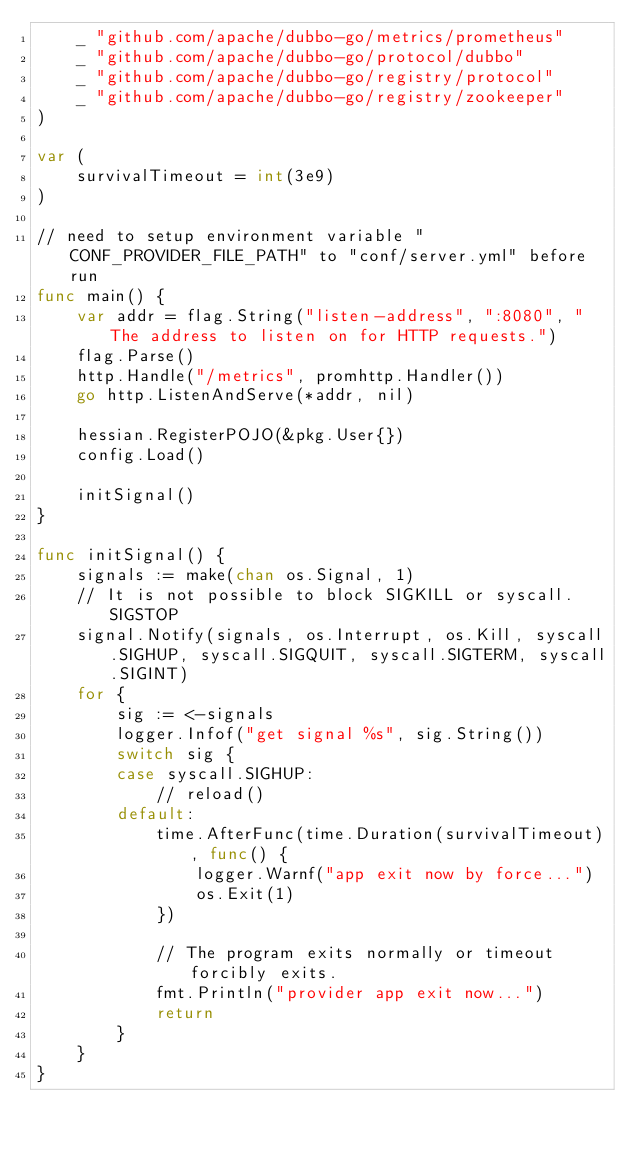Convert code to text. <code><loc_0><loc_0><loc_500><loc_500><_Go_>	_ "github.com/apache/dubbo-go/metrics/prometheus"
	_ "github.com/apache/dubbo-go/protocol/dubbo"
	_ "github.com/apache/dubbo-go/registry/protocol"
	_ "github.com/apache/dubbo-go/registry/zookeeper"
)

var (
	survivalTimeout = int(3e9)
)

// need to setup environment variable "CONF_PROVIDER_FILE_PATH" to "conf/server.yml" before run
func main() {
	var addr = flag.String("listen-address", ":8080", "The address to listen on for HTTP requests.")
	flag.Parse()
	http.Handle("/metrics", promhttp.Handler())
	go http.ListenAndServe(*addr, nil)

	hessian.RegisterPOJO(&pkg.User{})
	config.Load()

	initSignal()
}

func initSignal() {
	signals := make(chan os.Signal, 1)
	// It is not possible to block SIGKILL or syscall.SIGSTOP
	signal.Notify(signals, os.Interrupt, os.Kill, syscall.SIGHUP, syscall.SIGQUIT, syscall.SIGTERM, syscall.SIGINT)
	for {
		sig := <-signals
		logger.Infof("get signal %s", sig.String())
		switch sig {
		case syscall.SIGHUP:
			// reload()
		default:
			time.AfterFunc(time.Duration(survivalTimeout), func() {
				logger.Warnf("app exit now by force...")
				os.Exit(1)
			})

			// The program exits normally or timeout forcibly exits.
			fmt.Println("provider app exit now...")
			return
		}
	}
}
</code> 